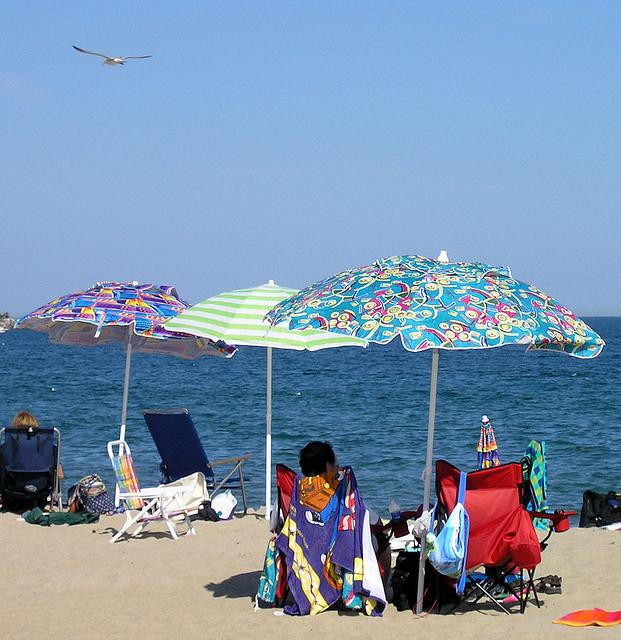What is the water like?
Be succinct. Choppy. Is the umbrellas protecting people from the bird?
Write a very short answer. No. Is this an overcast day?
Short answer required. No. 